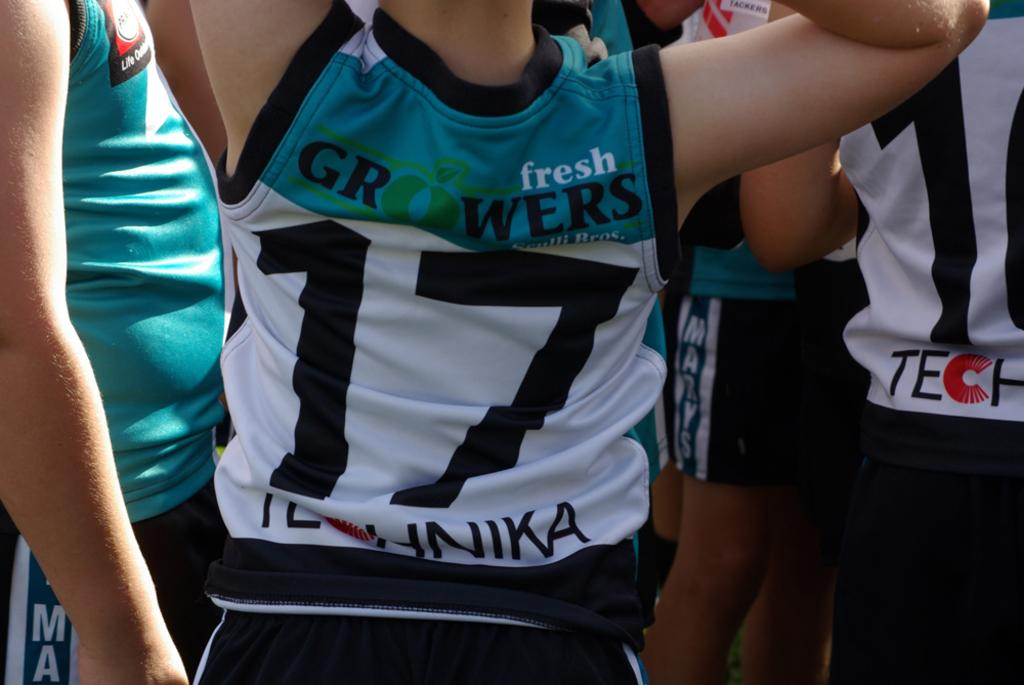Provide a one-sentence caption for the provided image. A person is wearing a fresh growers jersey with the number 17 on it. 